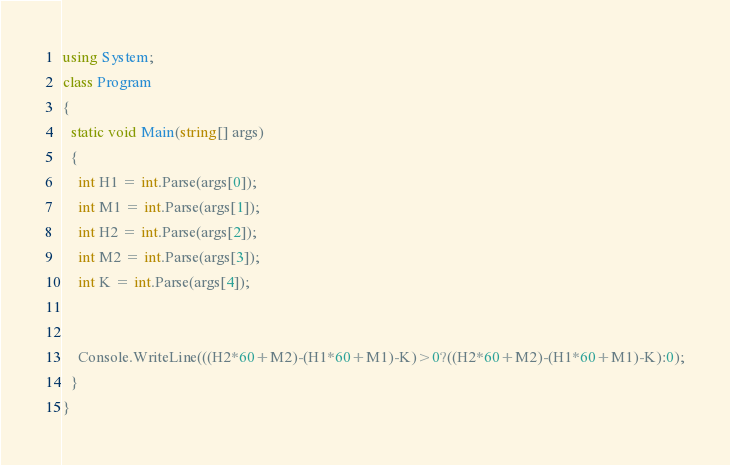Convert code to text. <code><loc_0><loc_0><loc_500><loc_500><_C#_>using System;
class Program
{
  static void Main(string[] args)
  {
    int H1 = int.Parse(args[0]);
    int M1 = int.Parse(args[1]);
    int H2 = int.Parse(args[2]);
    int M2 = int.Parse(args[3]);
    int K = int.Parse(args[4]);


    Console.WriteLine(((H2*60+M2)-(H1*60+M1)-K)>0?((H2*60+M2)-(H1*60+M1)-K):0);
  }
}
</code> 